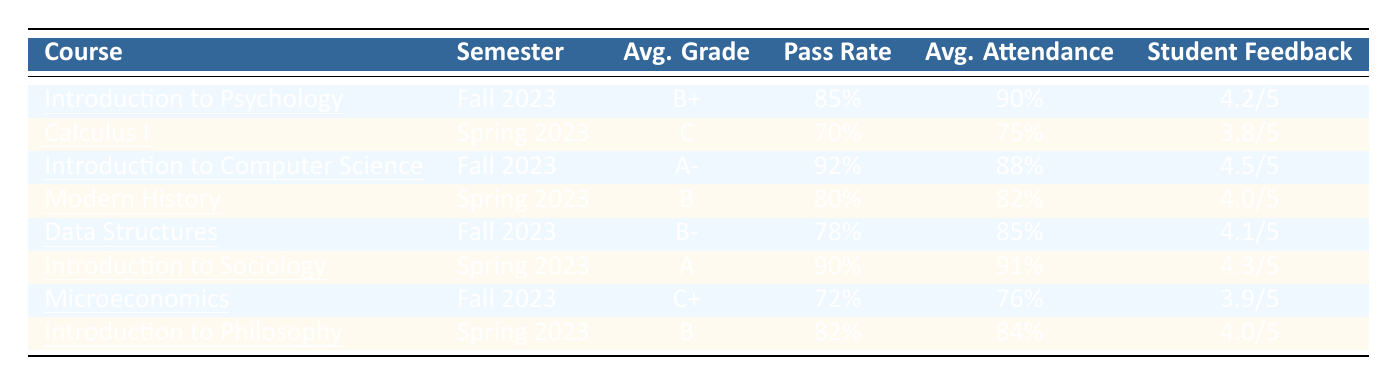What is the average grade for "Data Structures"? The average grade for "Data Structures" is specified directly in the table under the "Avg. Grade" column, which shows a grade of B-.
Answer: B- Which course has the highest pass rate? The course with the highest pass rate is found by comparing the "Pass Rate" values in the table. "Introduction to Computer Science" has the highest pass rate at 92%.
Answer: Introduction to Computer Science What is the average attendance for "Introduction to Sociology"? The average attendance for "Introduction to Sociology" is directly listed in the table, showing 91% under the "Avg. Attendance" column.
Answer: 91% Is the student feedback score for "Calculus I" above 4.0? To determine if the student feedback score for "Calculus I" is above 4.0, we reference the "Student Feedback" column, which shows a score of 3.8/5, indicating it is not above 4.0.
Answer: No Calculate the average of the student feedback scores for all courses offered in Fall 2023. The student feedback scores for Fall 2023 courses "Introduction to Psychology", "Introduction to Computer Science", "Data Structures", and "Microeconomics" are 4.2, 4.5, 4.1, and 3.9 respectively. First, sum these scores: 4.2 + 4.5 + 4.1 + 3.9 = 16.7. Then, divide by the number of courses, which is 4: 16.7 / 4 = 4.175.
Answer: 4.175 How does the average grade for "Microeconomics" compare to that of "Modern History"? To compare the average grades, we look at the respective grades: "Microeconomics" has an average grade of C+ and "Modern History" has an average grade of B. Since B is higher than C+, "Modern History" has a better average grade.
Answer: Modern History is higher What are the two courses with the lowest average attendance? We check the "Avg. Attendance" column, identifying the lowest values. "Calculus I" is at 75% and "Microeconomics" at 76%. Therefore, the two courses with the lowest average attendance are "Calculus I" and "Microeconomics".
Answer: Calculus I and Microeconomics If a student wanted to enroll in the course with the best student feedback score, which course should they choose? We look at the "Student Feedback" column and find that "Introduction to Computer Science" has the highest score at 4.5/5, suggesting it is the best course for student feedback.
Answer: Introduction to Computer Science What is the difference in pass rates between "Data Structures" and "Introduction to Philosophy"? We find the pass rates from the table: "Data Structures" has a pass rate of 78% and "Introduction to Philosophy" has 82%. The difference can be calculated by subtracting: 82% - 78% = 4%.
Answer: 4% How many courses have an average grade of B or higher? We identify the courses with an average grade of B or higher: "Introduction to Psychology" (B+), "Introduction to Computer Science" (A-), "Introduction to Sociology" (A), "Modern History" (B), and "Introduction to Philosophy" (B). There are 5 courses in total.
Answer: 5 courses 